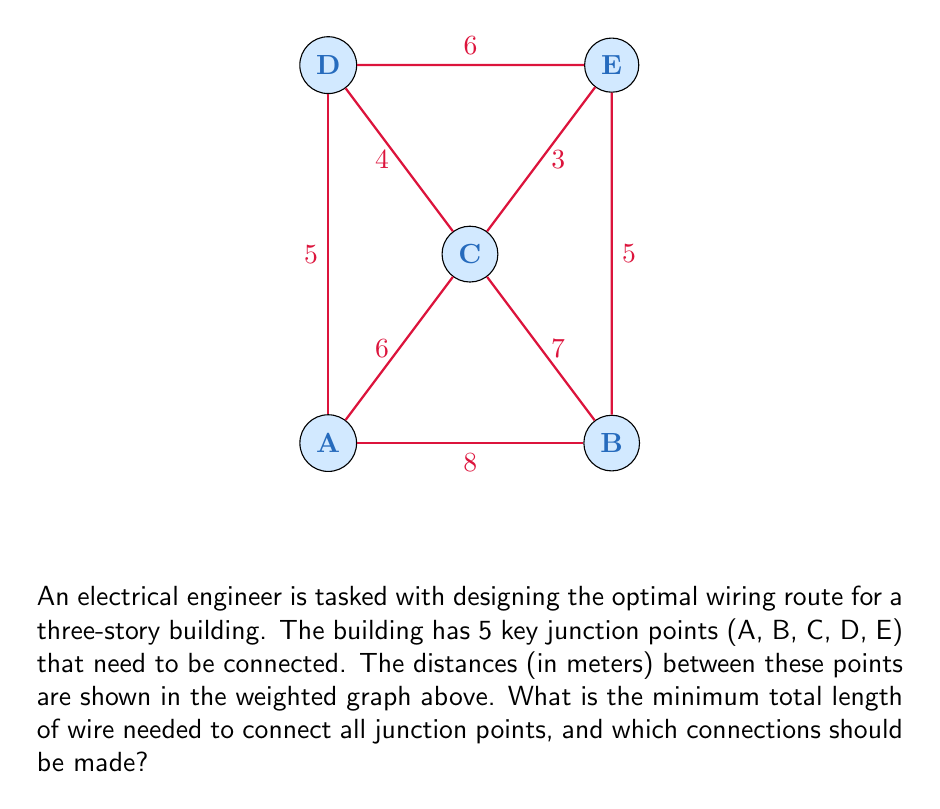Solve this math problem. To solve this problem, we can use Kruskal's algorithm to find the Minimum Spanning Tree (MST) of the given graph. This will give us the optimal routing for the wiring installation.

Step 1: Sort all edges by weight in ascending order:
1. C-E: 3m
2. C-D: 4m
3. A-D: 5m
4. B-E: 5m
5. A-C: 6m
6. D-E: 6m
7. B-C: 7m
8. A-B: 8m

Step 2: Apply Kruskal's algorithm:
1. Add C-E (3m)
2. Add C-D (4m)
3. Add A-D (5m)
4. Add B-E (5m)

At this point, all vertices are connected, and we have our MST.

Step 3: Calculate the total length of wire needed:
$$ \text{Total length} = 3m + 4m + 5m + 5m = 17m $$

The optimal connections are:
1. C to E
2. C to D
3. A to D
4. B to E

This solution ensures that all junction points are connected using the minimum amount of wire, which is crucial for cost-effective and efficient wiring installation in complex building structures.
Answer: 17 meters; connections: C-E, C-D, A-D, B-E 